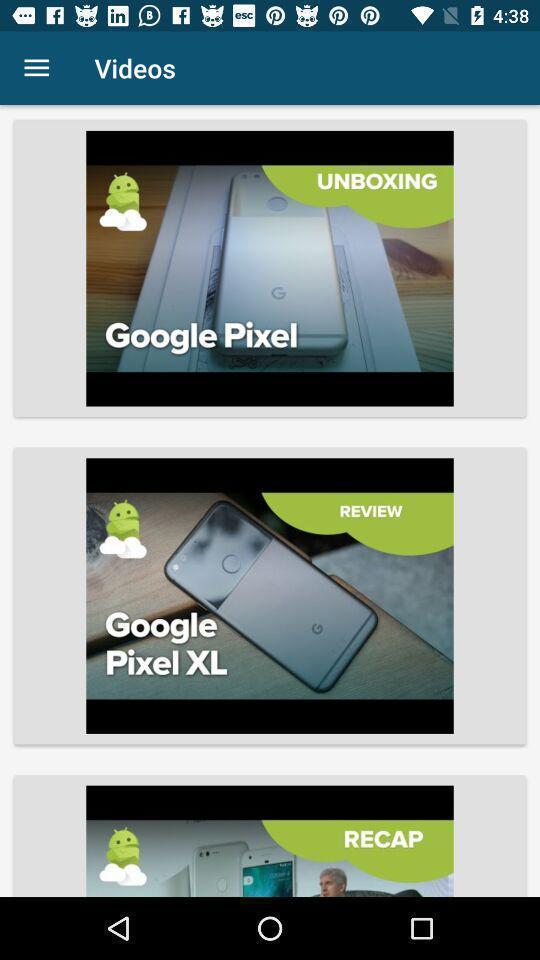Provide a textual representation of this image. Videos of a google pixel. 